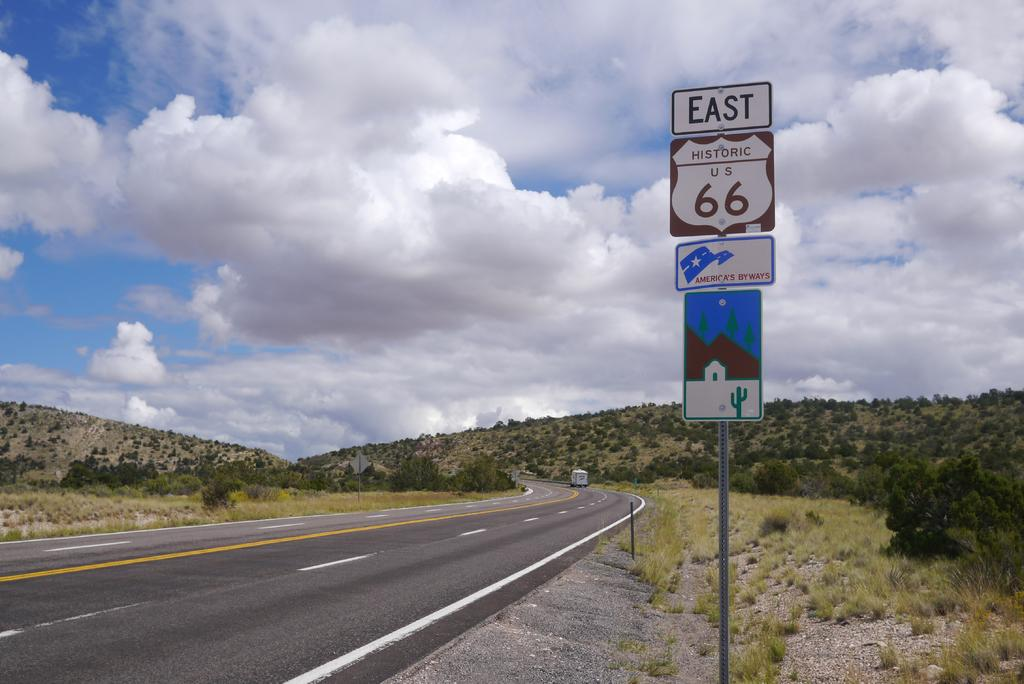<image>
Create a compact narrative representing the image presented. A nearly deserted highway with the word East and the number 66 on a sign. 